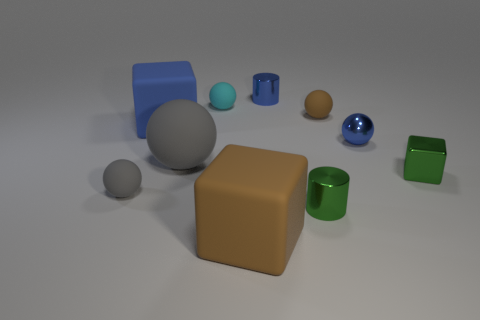Subtract 1 balls. How many balls are left? 4 Subtract all cyan balls. How many balls are left? 4 Subtract all big gray balls. How many balls are left? 4 Subtract all green cubes. Subtract all blue cylinders. How many cubes are left? 2 Subtract all blocks. How many objects are left? 7 Add 3 large rubber cylinders. How many large rubber cylinders exist? 3 Subtract 1 blue balls. How many objects are left? 9 Subtract all tiny cyan spheres. Subtract all blue metallic cylinders. How many objects are left? 8 Add 4 gray matte spheres. How many gray matte spheres are left? 6 